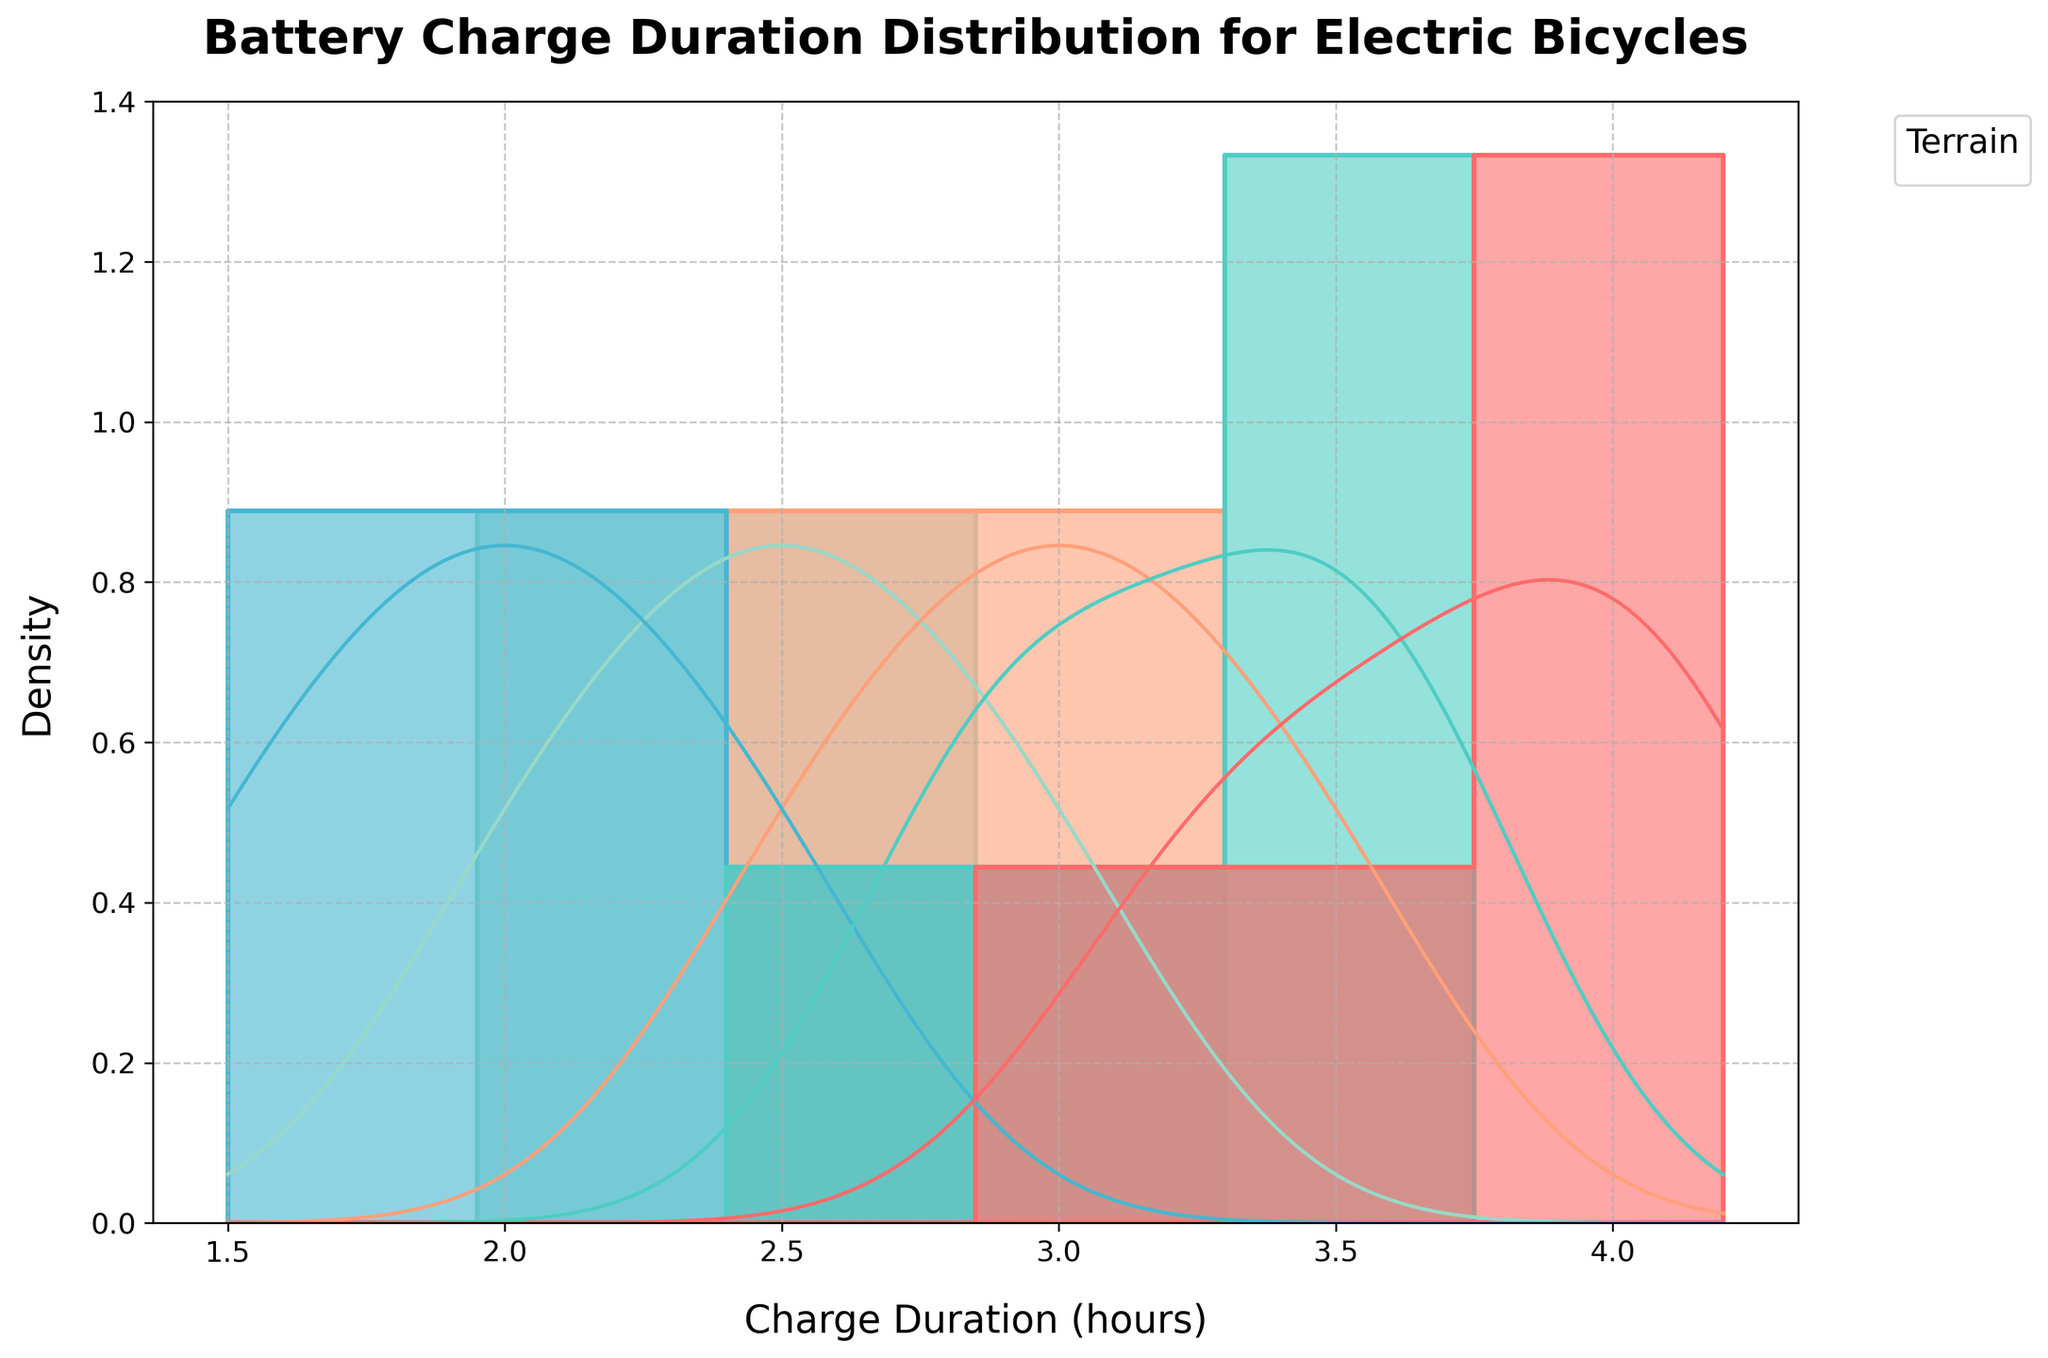What is the title of the plot? The title of the plot is displayed at the top of the figure, surrounded by the visual elements. The title summarizes the data being visualized.
Answer: Battery Charge Duration Distribution for Electric Bicycles What variable is on the x-axis? The x-axis represents the variable for which the data is being measured. In this case, the label on the x-axis will tell us.
Answer: Charge Duration (hours) How does the density curve for the Mountain terrain compare with the City terrain in terms of peak location? Comparing the position of the peaks in the density curves for the Mountain and City terrains on the x-axis shows where the highest density occurs for each terrain.
Answer: The Mountain peak is lower on the x-axis than the City peak Which terrain has the widest spread in battery charge duration times? The spread of the distribution for each terrain can be seen by examining the width of the histogram bars and the KDE curve. The wider the spread, the more variety in charge durations.
Answer: City What is the approximate range for the battery charge duration times in the Suburban terrain? The range is the difference between the maximum and minimum values observed for a terrain. By looking at the histogram bars and KDE curve for Suburban terrain, we can infer this range.
Answer: 2.8 to 3.7 hours Does the Beach terrain show any overlap in battery charge duration times with the Forest terrain? Checking for overlap involves comparing the distribution ranges of both terrains on the x-axis and observing if there are any common areas where their histogram bars or KDE curves coincide.
Answer: Yes In terms of charge duration, which terrain has distributions centered around higher durations, City or Beach? Observing the KDE peaks for both terrains provides information on where the distributions are centered. The higher KDE peak position on the x-axis indicates higher charge duration.
Answer: City Which terrain accounts for the most consistent battery charge duration times? Consistency can be inferred from how narrow and peaked the KDE curve is, indicating less variation in charge duration times.
Answer: Mountain How does the variance in battery charge duration times compare between Forest and Suburban? Variance is indicated by how spread out the histogram and KDE curves are. The more spread out the data, the higher the variance.
Answer: Suburban has higher variance than Forest 